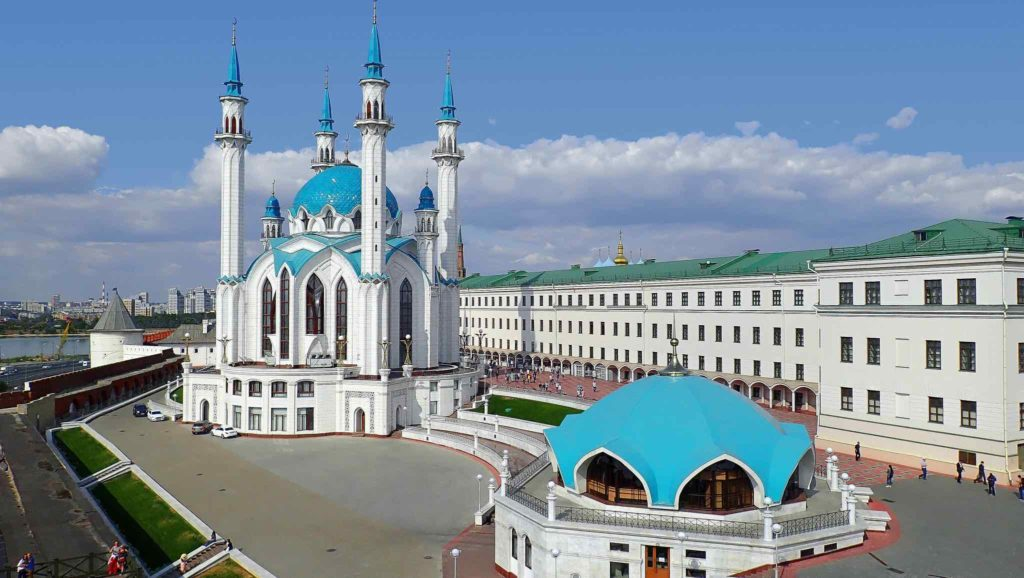Can you describe the architectural style of the mosque? The Kul Sharif Mosque exemplifies a unique blend of Islamic and Tatar architectural styles, reflecting the cultural diversity of Kazan. Its white façade and blue domes are characteristic of traditional Islamic mosque designs, while the intricate detailing and use of regional elements manifest Tatar influences. The mosque features four minarets that soar towards the sky, each adorned with decorative elements that enhance its grandeur. Inside, the mosque is equally captivating, with ornate patterns, calligraphy, and chandeliers that contribute to its divine atmosphere. What purpose does the other building serve? The green-roofed building adjacent to the Kul Sharif Mosque is the Presidential Palace, which serves as the official residence of the President of Tatarstan. This grand building is pivotal in the administrative and political functions of the region, housing significant government offices and serving as a venue for important state functions and meetings. 